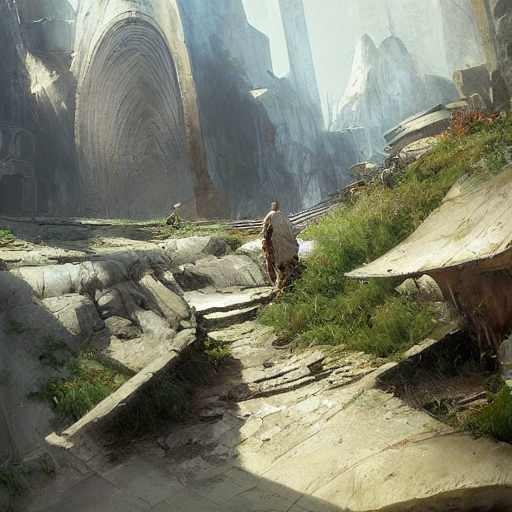Can you tell me more about the setting of this image? Certainly! The image presents a scene of ancient ruins, reminiscent of an old civilization. The architecture includes large, curved doorways and fragmented structures that suggest a once-grand edifice now reclaimed by nature. The setting exudes a quiet solitude, augmented by the soft lighting and overgrown vegetation, hinting at long passages of time since the place was last inhabited. 